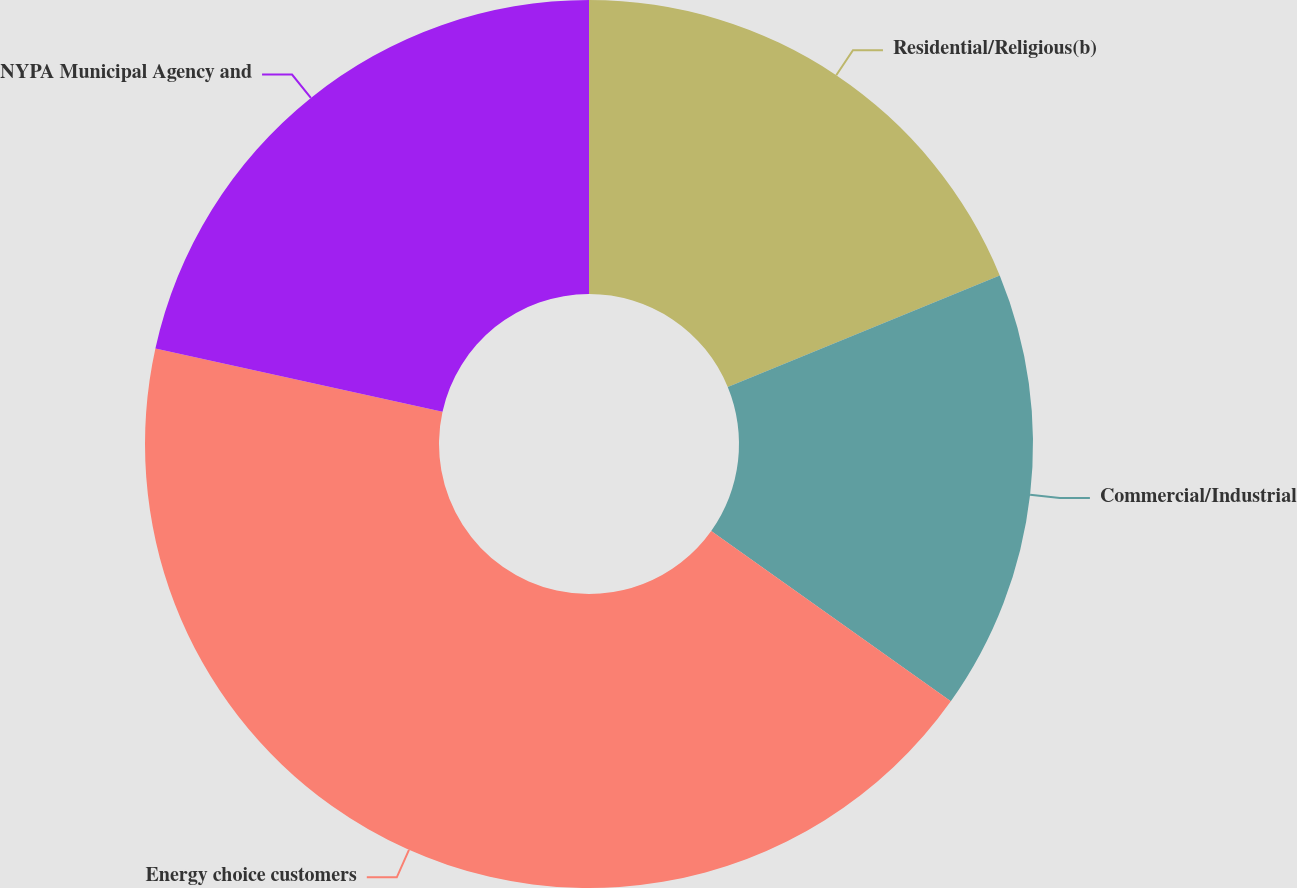Convert chart to OTSL. <chart><loc_0><loc_0><loc_500><loc_500><pie_chart><fcel>Residential/Religious(b)<fcel>Commercial/Industrial<fcel>Energy choice customers<fcel>NYPA Municipal Agency and<nl><fcel>18.8%<fcel>16.04%<fcel>43.61%<fcel>21.55%<nl></chart> 